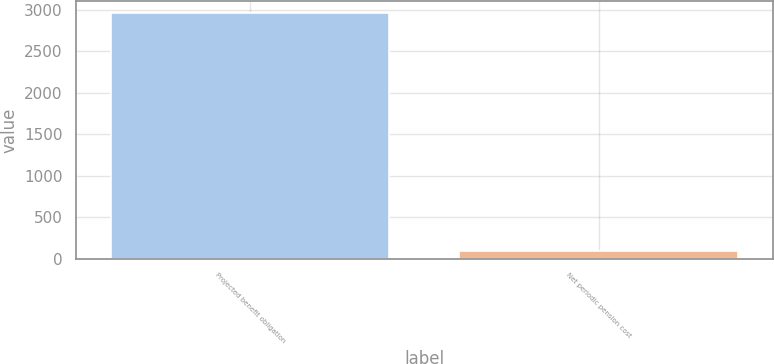Convert chart to OTSL. <chart><loc_0><loc_0><loc_500><loc_500><bar_chart><fcel>Projected benefit obligation<fcel>Net periodic pension cost<nl><fcel>2961<fcel>99<nl></chart> 